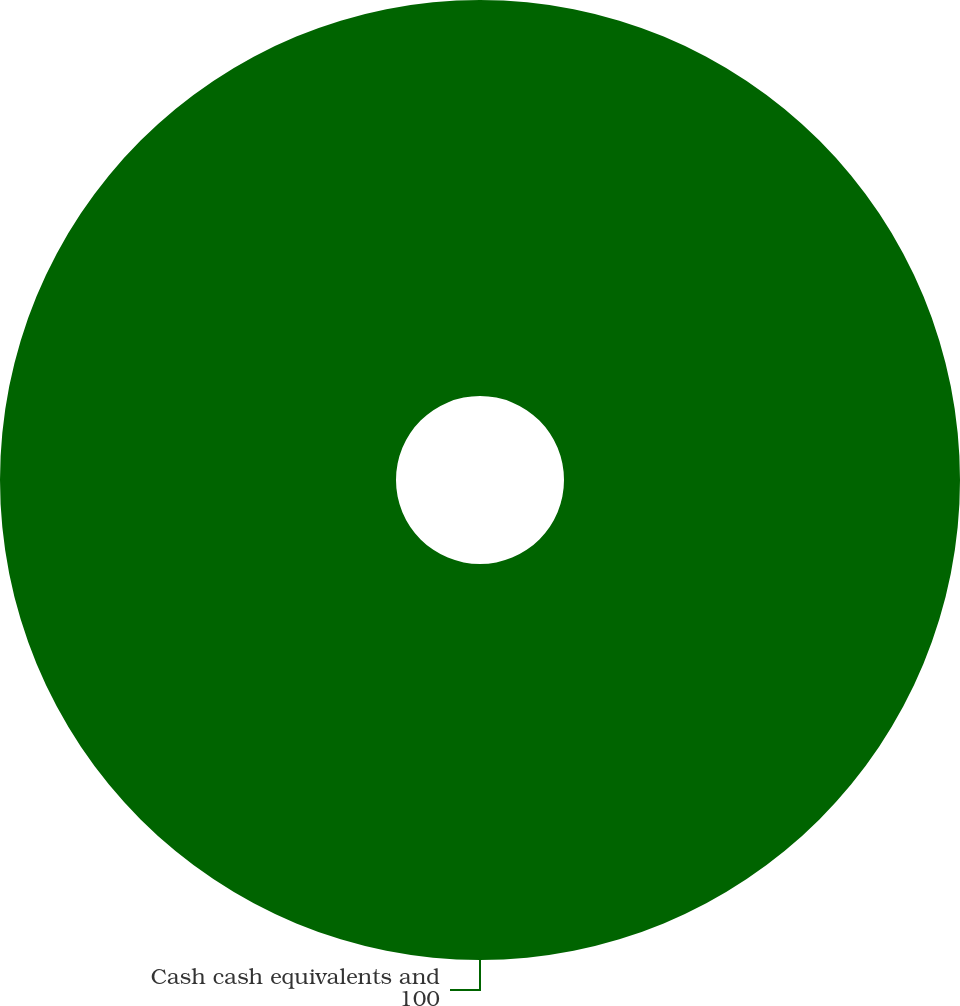Convert chart to OTSL. <chart><loc_0><loc_0><loc_500><loc_500><pie_chart><fcel>Cash cash equivalents and<nl><fcel>100.0%<nl></chart> 